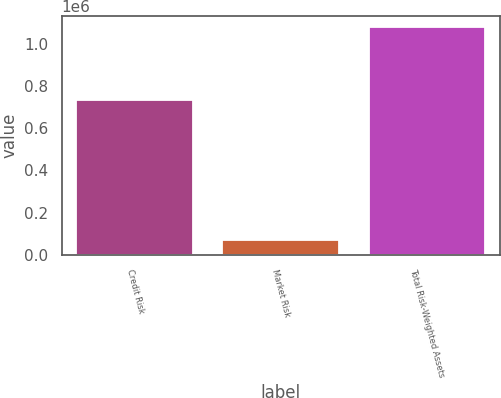<chart> <loc_0><loc_0><loc_500><loc_500><bar_chart><fcel>Credit Risk<fcel>Market Risk<fcel>Total Risk-Weighted Assets<nl><fcel>731515<fcel>70701<fcel>1.07814e+06<nl></chart> 